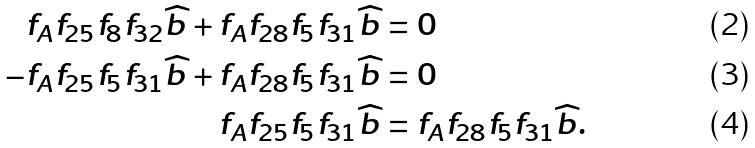Convert formula to latex. <formula><loc_0><loc_0><loc_500><loc_500>f _ { A } f _ { 2 5 } f _ { 8 } f _ { 3 2 } \widehat { b } + f _ { A } f _ { 2 8 } f _ { 5 } f _ { 3 1 } \widehat { b } & = 0 \\ - f _ { A } f _ { 2 5 } f _ { 5 } f _ { 3 1 } \widehat { b } + f _ { A } f _ { 2 8 } f _ { 5 } f _ { 3 1 } \widehat { b } & = 0 \\ f _ { A } f _ { 2 5 } f _ { 5 } f _ { 3 1 } \widehat { b } & = f _ { A } f _ { 2 8 } f _ { 5 } f _ { 3 1 } \widehat { b } .</formula> 